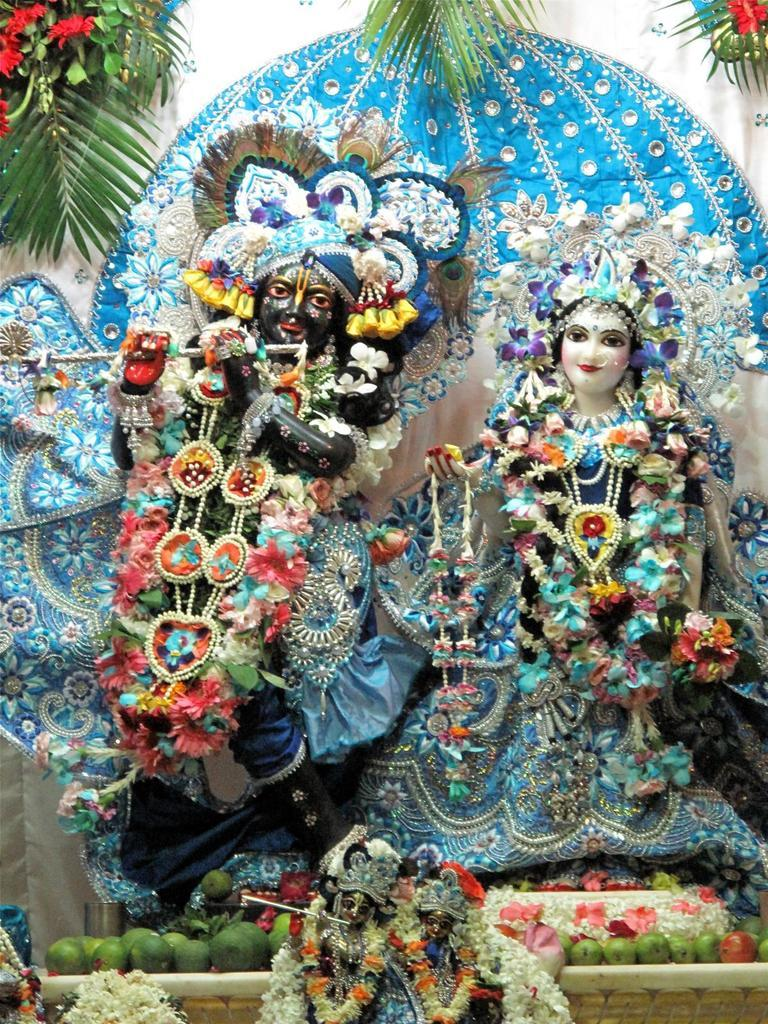What type of objects are present in the image? There are idols of god in the image. What decorative elements are present in the image? Garlands, leaves, flowers, and fruits are present in the image. Can you describe the objects in the image? The objects in the image are idols of god, garlands, leaves, flowers, and fruits. Is there a pig in the image? No, there is no pig present in the image. Can you tell me which brother is depicted in the image? There is no brother depicted in the image; it features idols of god. 